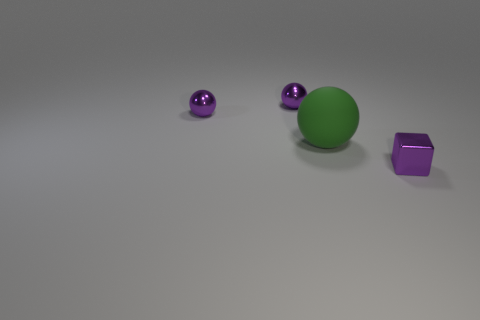Subtract all yellow cylinders. How many purple balls are left? 2 Subtract 1 spheres. How many spheres are left? 2 Add 4 small purple metallic balls. How many objects exist? 8 Subtract all cubes. How many objects are left? 3 Subtract all purple spheres. Subtract all cubes. How many objects are left? 1 Add 3 big objects. How many big objects are left? 4 Add 4 purple metal spheres. How many purple metal spheres exist? 6 Subtract 0 blue balls. How many objects are left? 4 